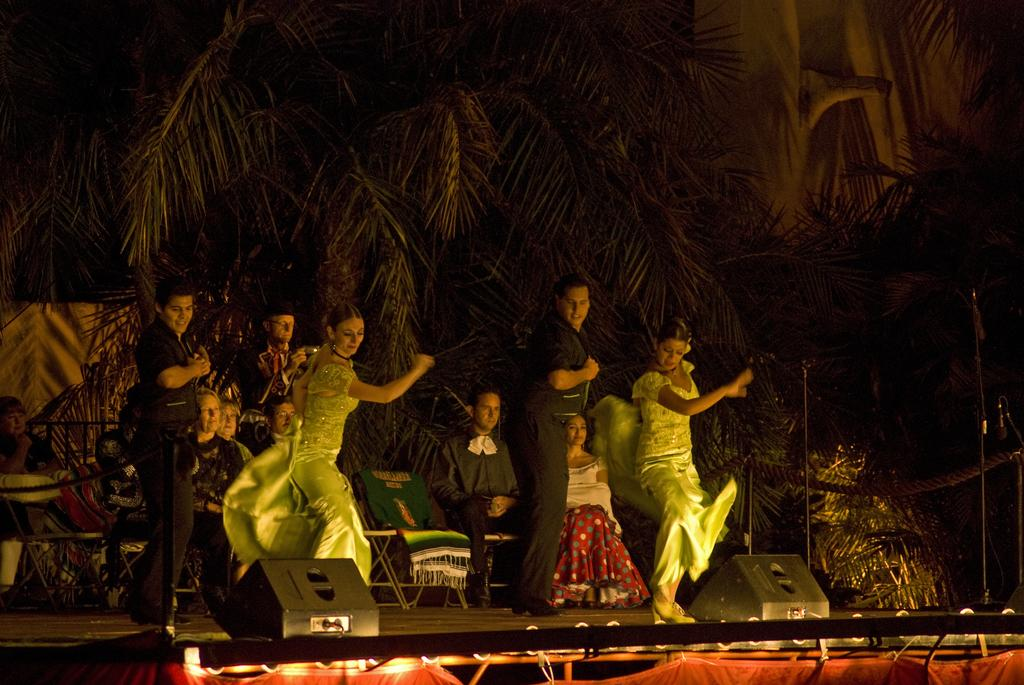How many people are in the group that is visible in the image? There is a group of people in the image. Can you describe the attire of one person in the group? One person in the group is wearing a black dress. What type of natural scenery can be seen in the background of the image? There are trees in the background of the image. What is the color of the trees in the image? The trees are green in color. What type of illumination is present in the image? There are lights visible in the image. How does the pollution affect the zebra in the image? There is no zebra present in the image, and therefore no pollution or its effects can be observed. 